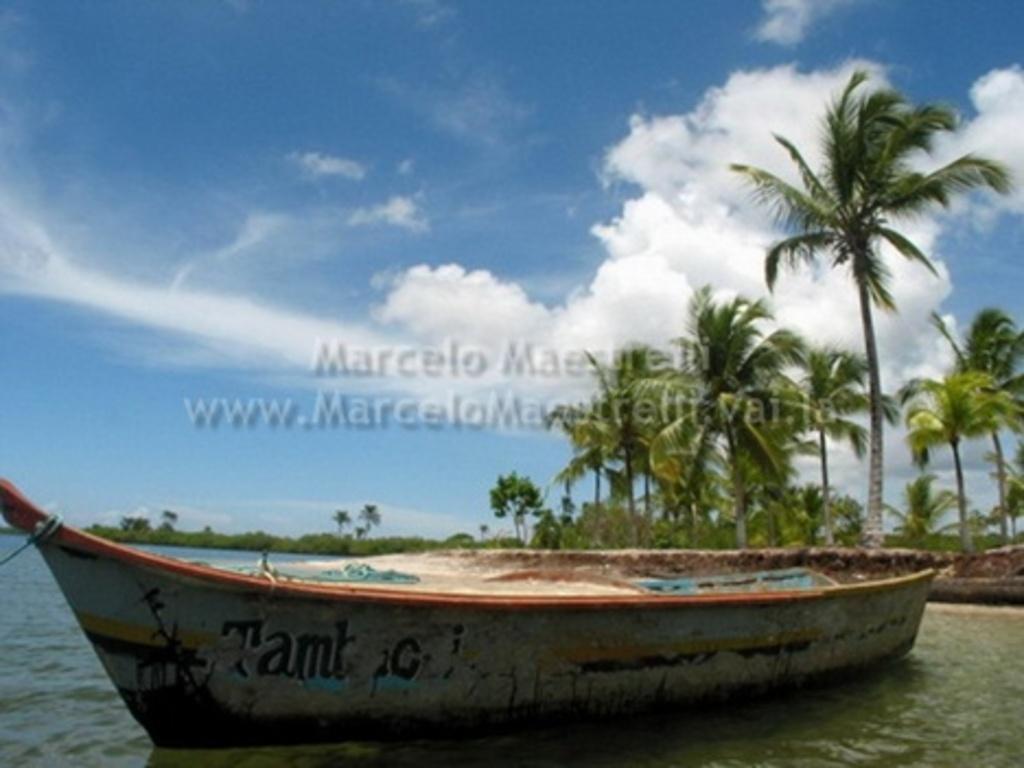Could you give a brief overview of what you see in this image? In this picture I can see a boat in the water and few trees and I can see a blue cloudy sky and I can see text in the middle of the picture. 